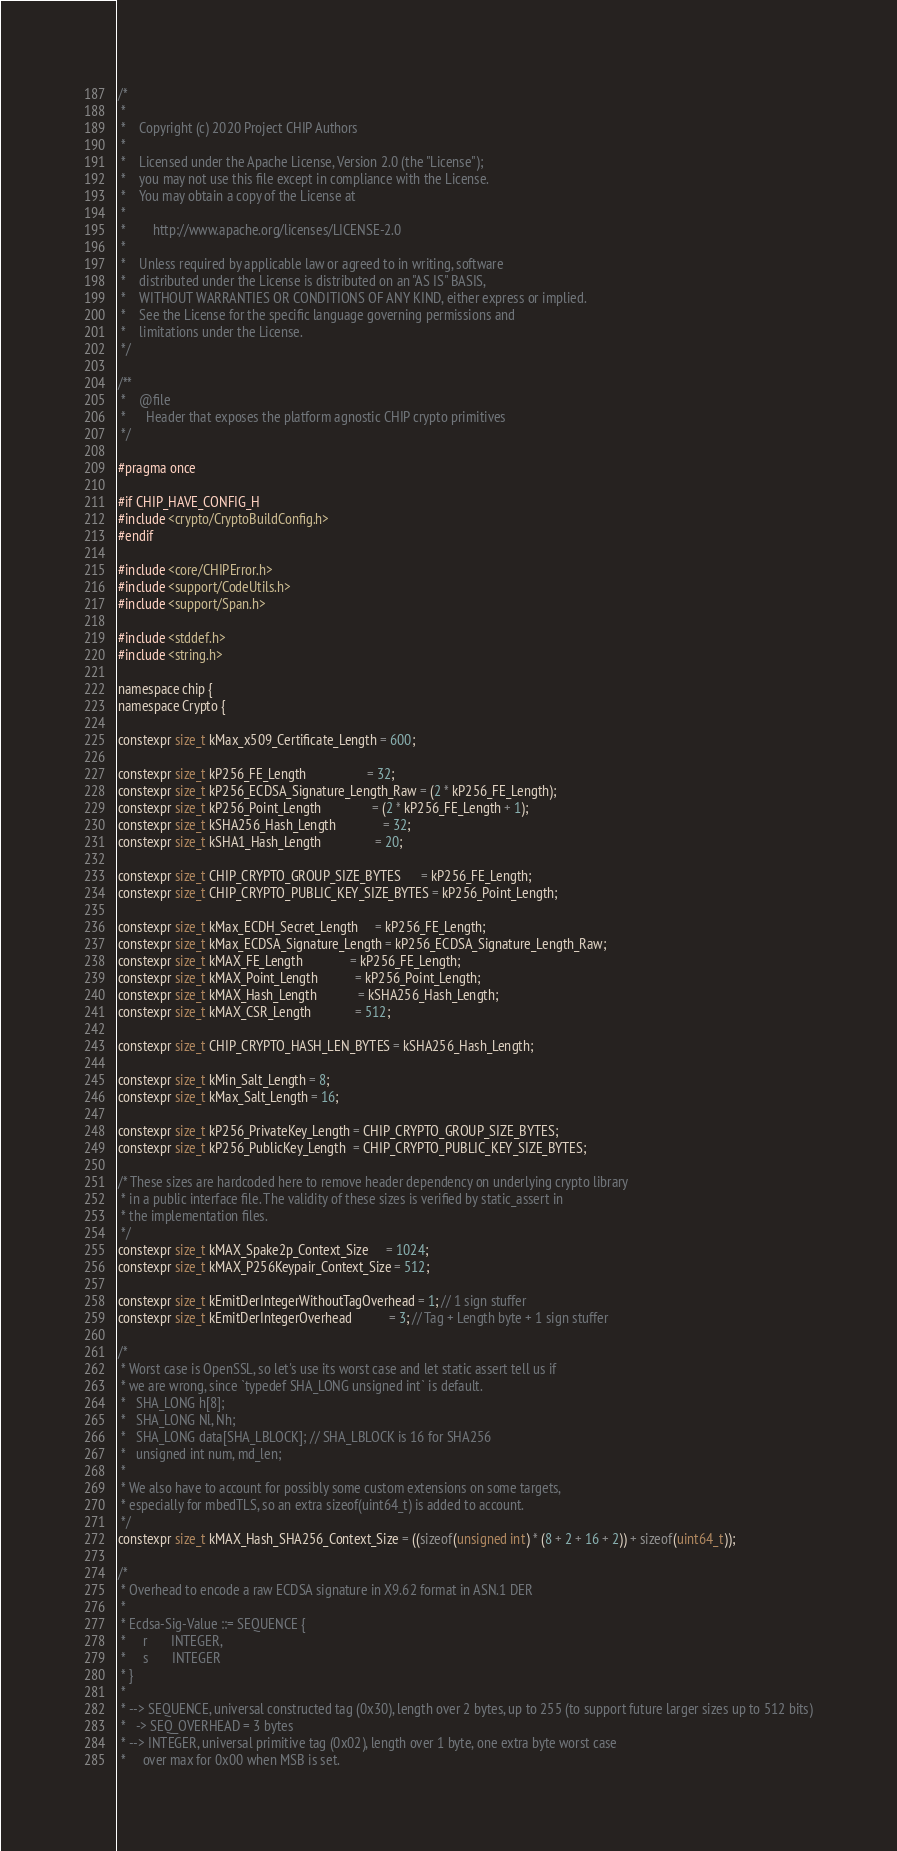Convert code to text. <code><loc_0><loc_0><loc_500><loc_500><_C_>/*
 *
 *    Copyright (c) 2020 Project CHIP Authors
 *
 *    Licensed under the Apache License, Version 2.0 (the "License");
 *    you may not use this file except in compliance with the License.
 *    You may obtain a copy of the License at
 *
 *        http://www.apache.org/licenses/LICENSE-2.0
 *
 *    Unless required by applicable law or agreed to in writing, software
 *    distributed under the License is distributed on an "AS IS" BASIS,
 *    WITHOUT WARRANTIES OR CONDITIONS OF ANY KIND, either express or implied.
 *    See the License for the specific language governing permissions and
 *    limitations under the License.
 */

/**
 *    @file
 *      Header that exposes the platform agnostic CHIP crypto primitives
 */

#pragma once

#if CHIP_HAVE_CONFIG_H
#include <crypto/CryptoBuildConfig.h>
#endif

#include <core/CHIPError.h>
#include <support/CodeUtils.h>
#include <support/Span.h>

#include <stddef.h>
#include <string.h>

namespace chip {
namespace Crypto {

constexpr size_t kMax_x509_Certificate_Length = 600;

constexpr size_t kP256_FE_Length                  = 32;
constexpr size_t kP256_ECDSA_Signature_Length_Raw = (2 * kP256_FE_Length);
constexpr size_t kP256_Point_Length               = (2 * kP256_FE_Length + 1);
constexpr size_t kSHA256_Hash_Length              = 32;
constexpr size_t kSHA1_Hash_Length                = 20;

constexpr size_t CHIP_CRYPTO_GROUP_SIZE_BYTES      = kP256_FE_Length;
constexpr size_t CHIP_CRYPTO_PUBLIC_KEY_SIZE_BYTES = kP256_Point_Length;

constexpr size_t kMax_ECDH_Secret_Length     = kP256_FE_Length;
constexpr size_t kMax_ECDSA_Signature_Length = kP256_ECDSA_Signature_Length_Raw;
constexpr size_t kMAX_FE_Length              = kP256_FE_Length;
constexpr size_t kMAX_Point_Length           = kP256_Point_Length;
constexpr size_t kMAX_Hash_Length            = kSHA256_Hash_Length;
constexpr size_t kMAX_CSR_Length             = 512;

constexpr size_t CHIP_CRYPTO_HASH_LEN_BYTES = kSHA256_Hash_Length;

constexpr size_t kMin_Salt_Length = 8;
constexpr size_t kMax_Salt_Length = 16;

constexpr size_t kP256_PrivateKey_Length = CHIP_CRYPTO_GROUP_SIZE_BYTES;
constexpr size_t kP256_PublicKey_Length  = CHIP_CRYPTO_PUBLIC_KEY_SIZE_BYTES;

/* These sizes are hardcoded here to remove header dependency on underlying crypto library
 * in a public interface file. The validity of these sizes is verified by static_assert in
 * the implementation files.
 */
constexpr size_t kMAX_Spake2p_Context_Size     = 1024;
constexpr size_t kMAX_P256Keypair_Context_Size = 512;

constexpr size_t kEmitDerIntegerWithoutTagOverhead = 1; // 1 sign stuffer
constexpr size_t kEmitDerIntegerOverhead           = 3; // Tag + Length byte + 1 sign stuffer

/*
 * Worst case is OpenSSL, so let's use its worst case and let static assert tell us if
 * we are wrong, since `typedef SHA_LONG unsigned int` is default.
 *   SHA_LONG h[8];
 *   SHA_LONG Nl, Nh;
 *   SHA_LONG data[SHA_LBLOCK]; // SHA_LBLOCK is 16 for SHA256
 *   unsigned int num, md_len;
 *
 * We also have to account for possibly some custom extensions on some targets,
 * especially for mbedTLS, so an extra sizeof(uint64_t) is added to account.
 */
constexpr size_t kMAX_Hash_SHA256_Context_Size = ((sizeof(unsigned int) * (8 + 2 + 16 + 2)) + sizeof(uint64_t));

/*
 * Overhead to encode a raw ECDSA signature in X9.62 format in ASN.1 DER
 *
 * Ecdsa-Sig-Value ::= SEQUENCE {
 *     r       INTEGER,
 *     s       INTEGER
 * }
 *
 * --> SEQUENCE, universal constructed tag (0x30), length over 2 bytes, up to 255 (to support future larger sizes up to 512 bits)
 *   -> SEQ_OVERHEAD = 3 bytes
 * --> INTEGER, universal primitive tag (0x02), length over 1 byte, one extra byte worst case
 *     over max for 0x00 when MSB is set.</code> 